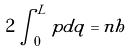<formula> <loc_0><loc_0><loc_500><loc_500>2 \int _ { 0 } ^ { L } p d q = n h</formula> 